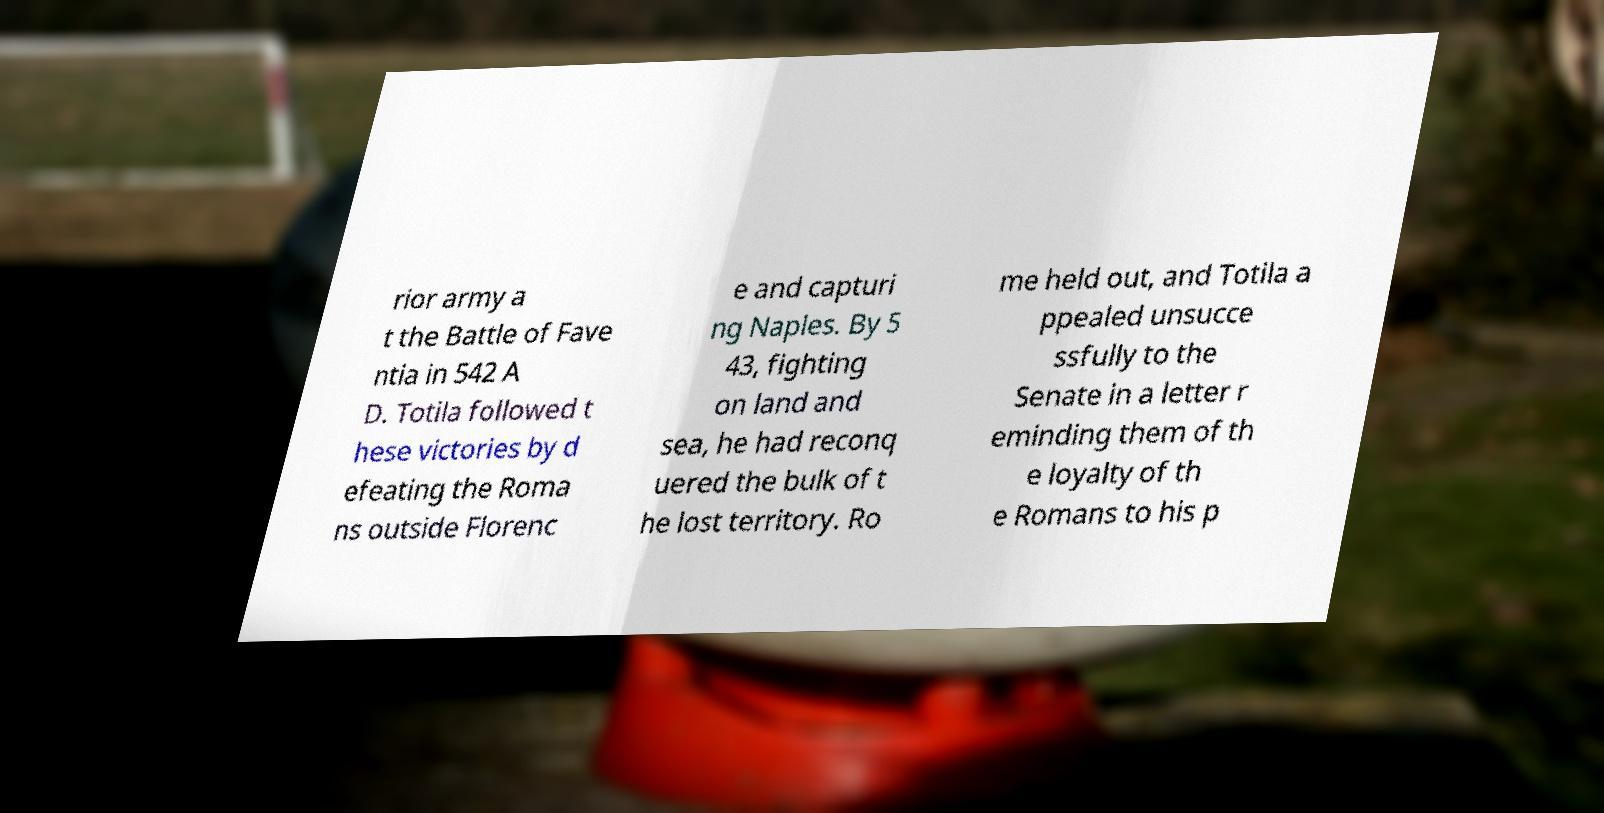For documentation purposes, I need the text within this image transcribed. Could you provide that? rior army a t the Battle of Fave ntia in 542 A D. Totila followed t hese victories by d efeating the Roma ns outside Florenc e and capturi ng Naples. By 5 43, fighting on land and sea, he had reconq uered the bulk of t he lost territory. Ro me held out, and Totila a ppealed unsucce ssfully to the Senate in a letter r eminding them of th e loyalty of th e Romans to his p 